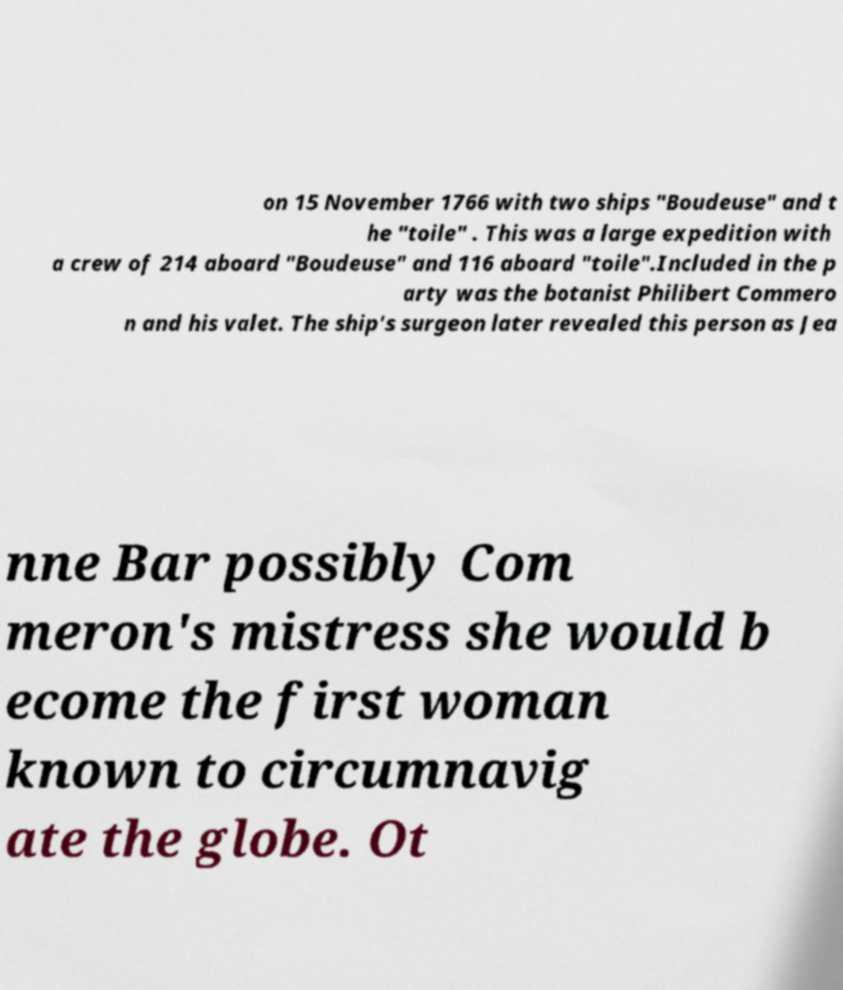Please identify and transcribe the text found in this image. on 15 November 1766 with two ships "Boudeuse" and t he "toile" . This was a large expedition with a crew of 214 aboard "Boudeuse" and 116 aboard "toile".Included in the p arty was the botanist Philibert Commero n and his valet. The ship's surgeon later revealed this person as Jea nne Bar possibly Com meron's mistress she would b ecome the first woman known to circumnavig ate the globe. Ot 